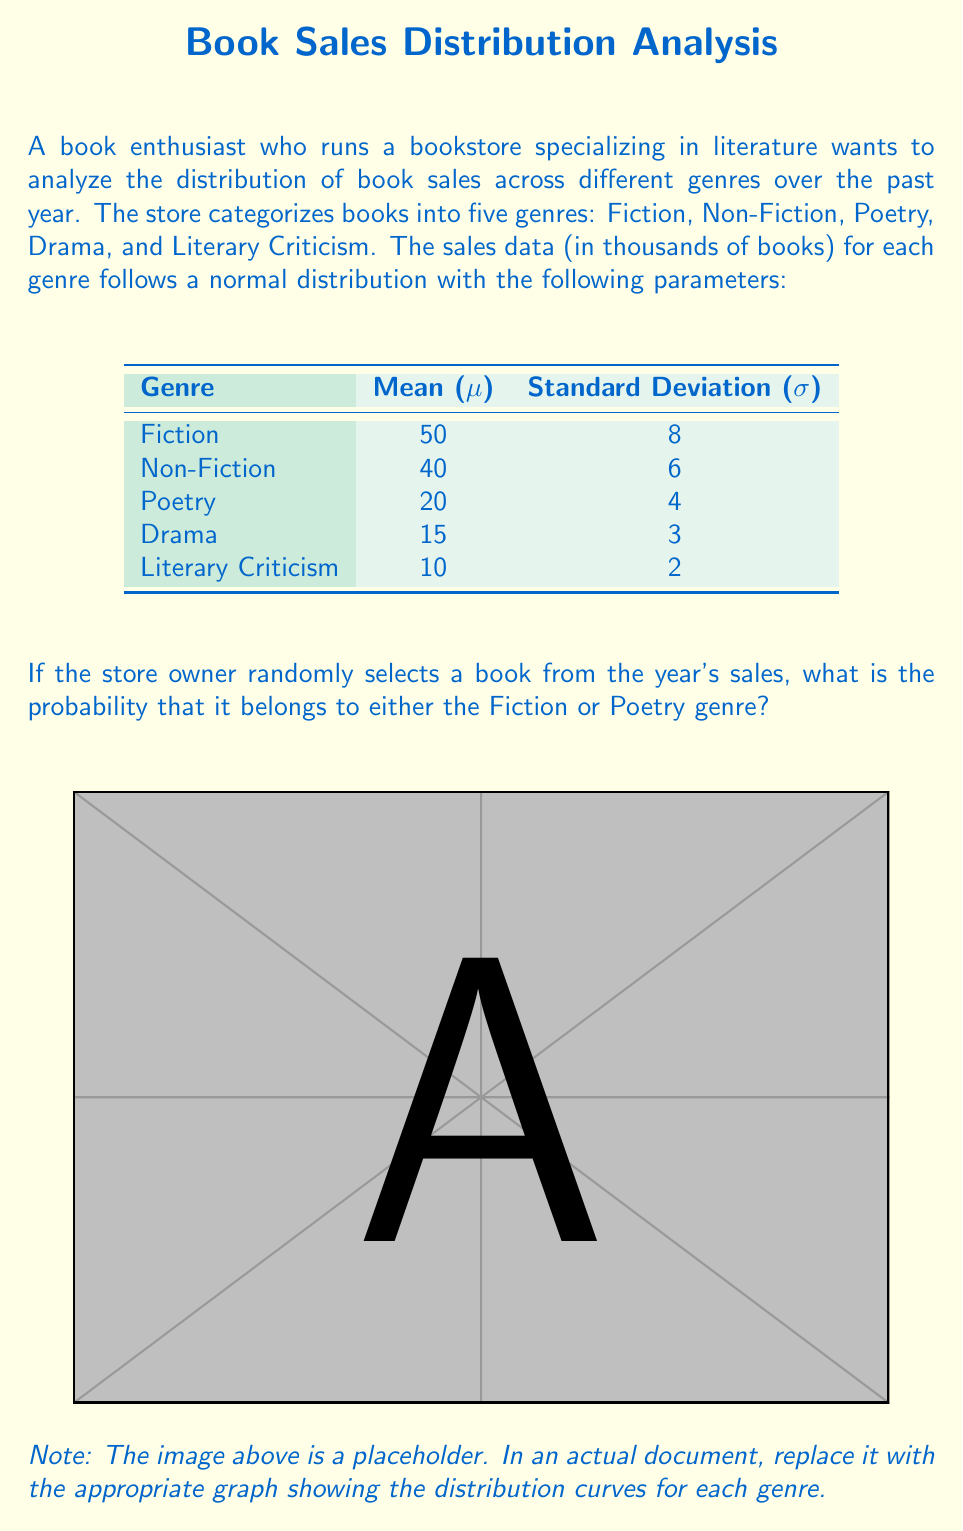Provide a solution to this math problem. To solve this problem, we need to calculate the total number of books sold for each genre and then find the proportion of Fiction and Poetry books combined. Let's follow these steps:

1) First, we need to calculate the total number of books sold for each genre. Since we're dealing with normal distributions, we can use the mean (μ) as our estimate for each genre's total sales.

   Fiction: 50,000
   Non-Fiction: 40,000
   Poetry: 20,000
   Drama: 15,000
   Literary Criticism: 10,000

2) Calculate the total number of books sold across all genres:

   Total = 50,000 + 40,000 + 20,000 + 15,000 + 10,000 = 135,000

3) Calculate the number of books sold in Fiction and Poetry combined:

   Fiction + Poetry = 50,000 + 20,000 = 70,000

4) Calculate the probability by dividing the number of Fiction and Poetry books by the total number of books:

   $$P(\text{Fiction or Poetry}) = \frac{70,000}{135,000} = \frac{70}{135} \approx 0.5185$$

5) Convert to a percentage:

   0.5185 * 100% ≈ 51.85%

Therefore, the probability that a randomly selected book belongs to either the Fiction or Poetry genre is approximately 51.85%.
Answer: 51.85% 